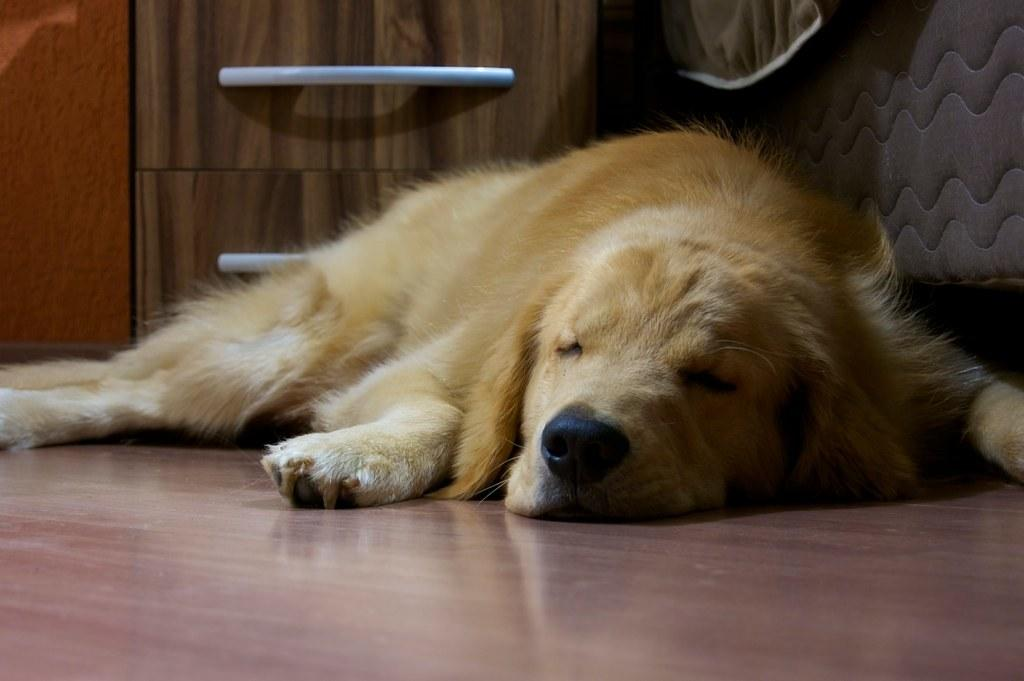What type of animal is in the image? There is a dog in the image. What is the dog doing in the image? The dog is sleeping on the wooden floor. What color is the dog? The dog is cream in color. Does the dog have fur? Yes, the dog has fur. What can be seen in the background of the image? There are draws in the background of the image. Where are the draws located in relation to the wall? The draws are near a wall. How many girls are interacting with the dog in the image? There are no girls present in the image; it only features a dog sleeping on the wooden floor. What type of digestion issues is the dog experiencing in the image? There is no indication of any digestion issues in the image; the dog is simply sleeping on the wooden floor. 